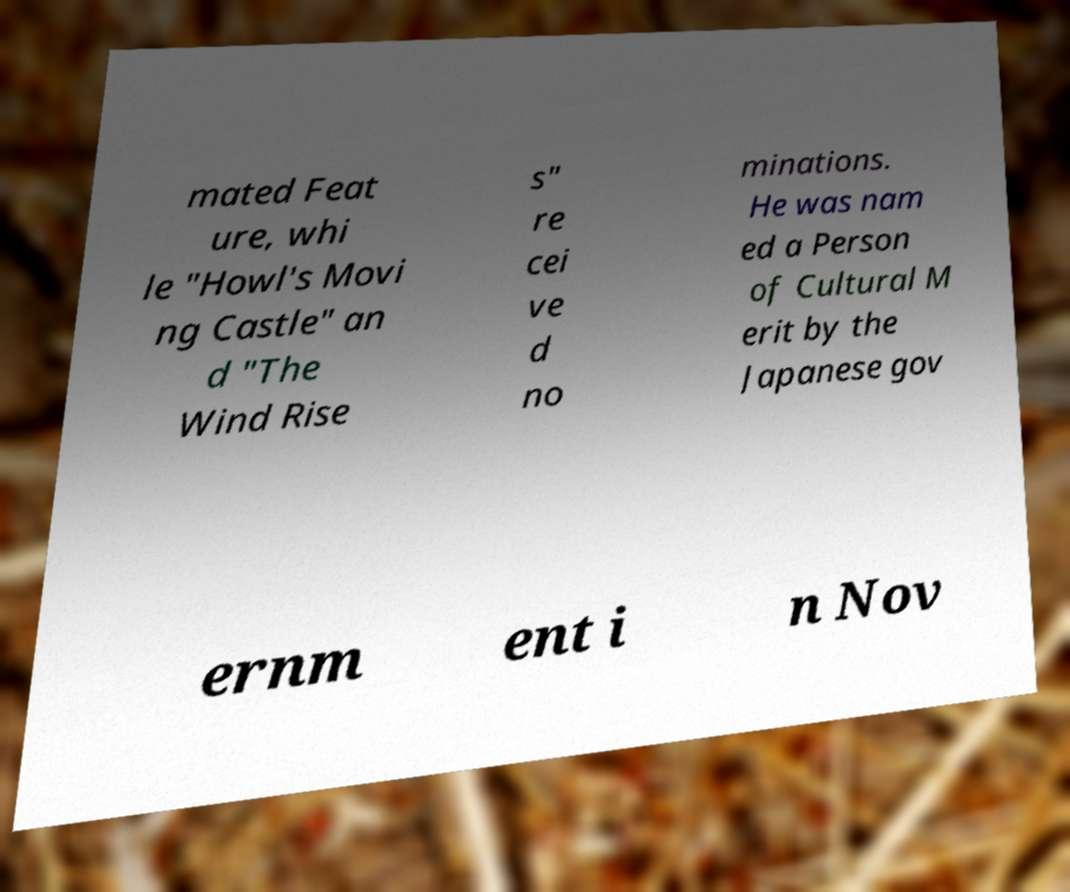Can you accurately transcribe the text from the provided image for me? mated Feat ure, whi le "Howl's Movi ng Castle" an d "The Wind Rise s" re cei ve d no minations. He was nam ed a Person of Cultural M erit by the Japanese gov ernm ent i n Nov 